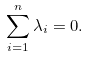<formula> <loc_0><loc_0><loc_500><loc_500>\sum _ { i = 1 } ^ { n } \lambda _ { i } = 0 .</formula> 